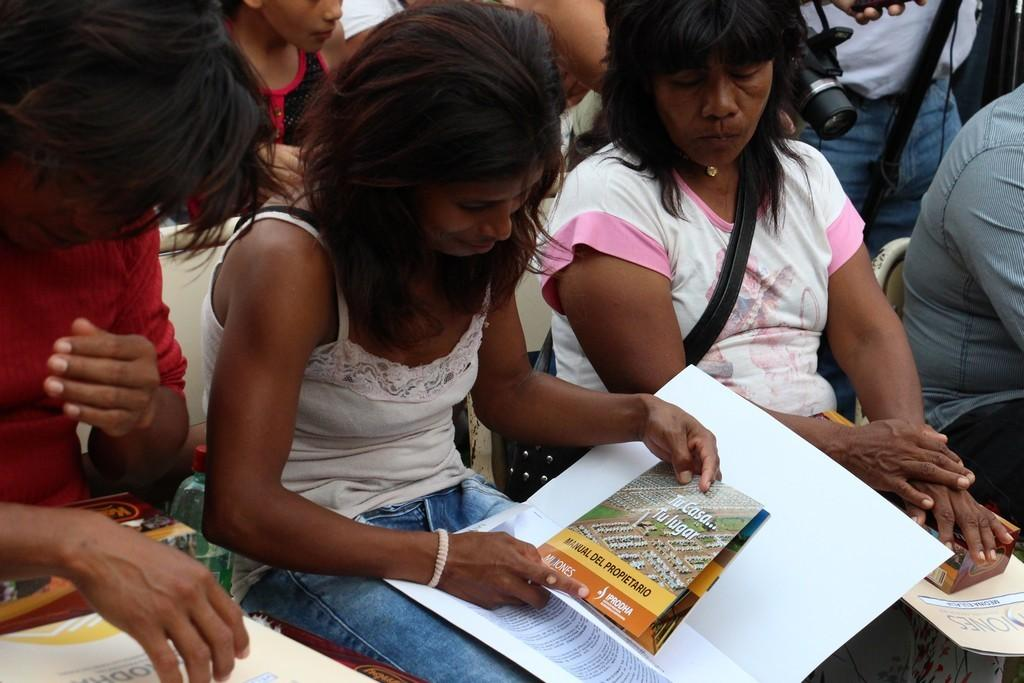What are the people in the image doing? The people in the image are sitting on chairs. Can you describe the woman in the image? The woman in the image is holding a paper in her hand. Are there any other papers visible in the image? Yes, there are additional papers visible in the image. What object is used for capturing images in the image? There is a camera present in the image. How many wheels are visible on the cars in the image? There are no cars visible in the image, so the number of wheels cannot be determined. 